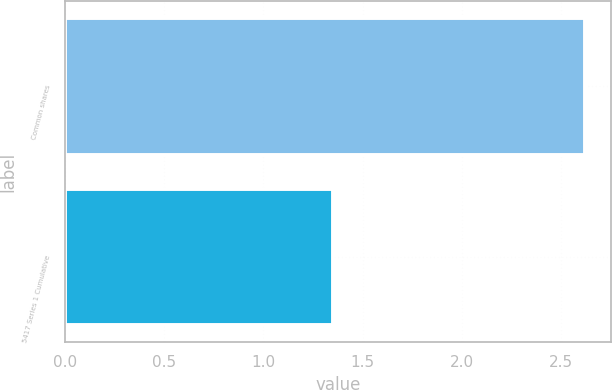<chart> <loc_0><loc_0><loc_500><loc_500><bar_chart><fcel>Common shares<fcel>5417 Series 1 Cumulative<nl><fcel>2.62<fcel>1.35<nl></chart> 